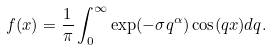<formula> <loc_0><loc_0><loc_500><loc_500>f ( x ) = \frac { 1 } { \pi } \int _ { 0 } ^ { \infty } \exp ( - \sigma q ^ { \alpha } ) \cos ( q x ) d q .</formula> 